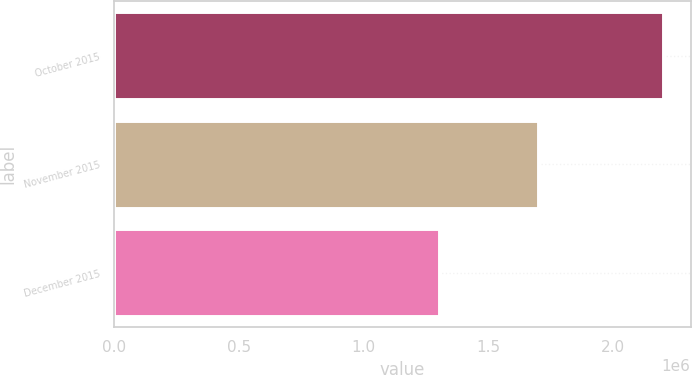<chart> <loc_0><loc_0><loc_500><loc_500><bar_chart><fcel>October 2015<fcel>November 2015<fcel>December 2015<nl><fcel>2.2e+06<fcel>1.7e+06<fcel>1.3e+06<nl></chart> 